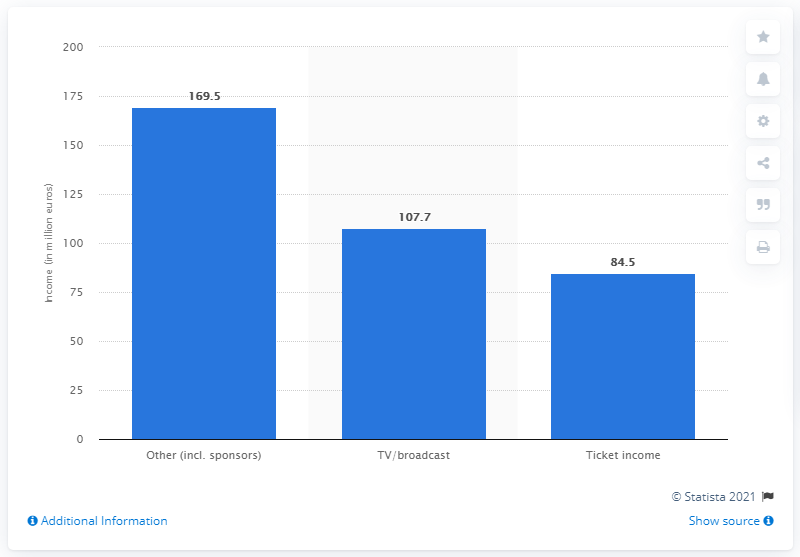Give some essential details in this illustration. In the 2011/12 season of the second-tier football division in Germany, the total income from ticketing among all 18 clubs was 84.5 million euros. 